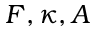Convert formula to latex. <formula><loc_0><loc_0><loc_500><loc_500>F , \kappa , A</formula> 